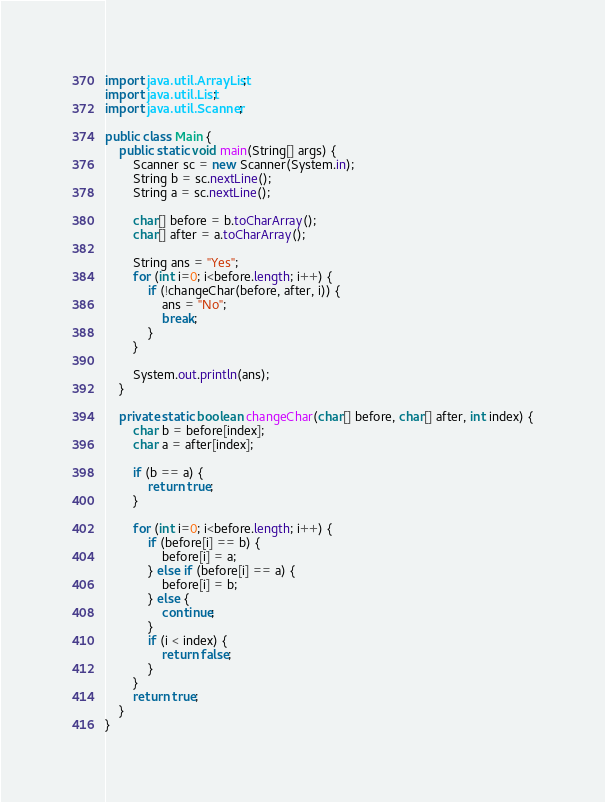Convert code to text. <code><loc_0><loc_0><loc_500><loc_500><_Java_>import java.util.ArrayList;
import java.util.List;
import java.util.Scanner;

public class Main {
	public static void main(String[] args) {
		Scanner sc = new Scanner(System.in);
		String b = sc.nextLine();
		String a = sc.nextLine();
		
		char[] before = b.toCharArray();
		char[] after = a.toCharArray();
		
		String ans = "Yes";
		for (int i=0; i<before.length; i++) {
			if (!changeChar(before, after, i)) {
				ans = "No";
				break;
			}
		}

		System.out.println(ans);
	}
	
	private static boolean changeChar(char[] before, char[] after, int index) {
		char b = before[index];
		char a = after[index];

		if (b == a) {
			return true;
		}

		for (int i=0; i<before.length; i++) {
			if (before[i] == b) {
				before[i] = a;
			} else if (before[i] == a) {
				before[i] = b;
			} else {
				continue;
			}
			if (i < index) {
				return false;
			}
		}
		return true;
	}
}</code> 